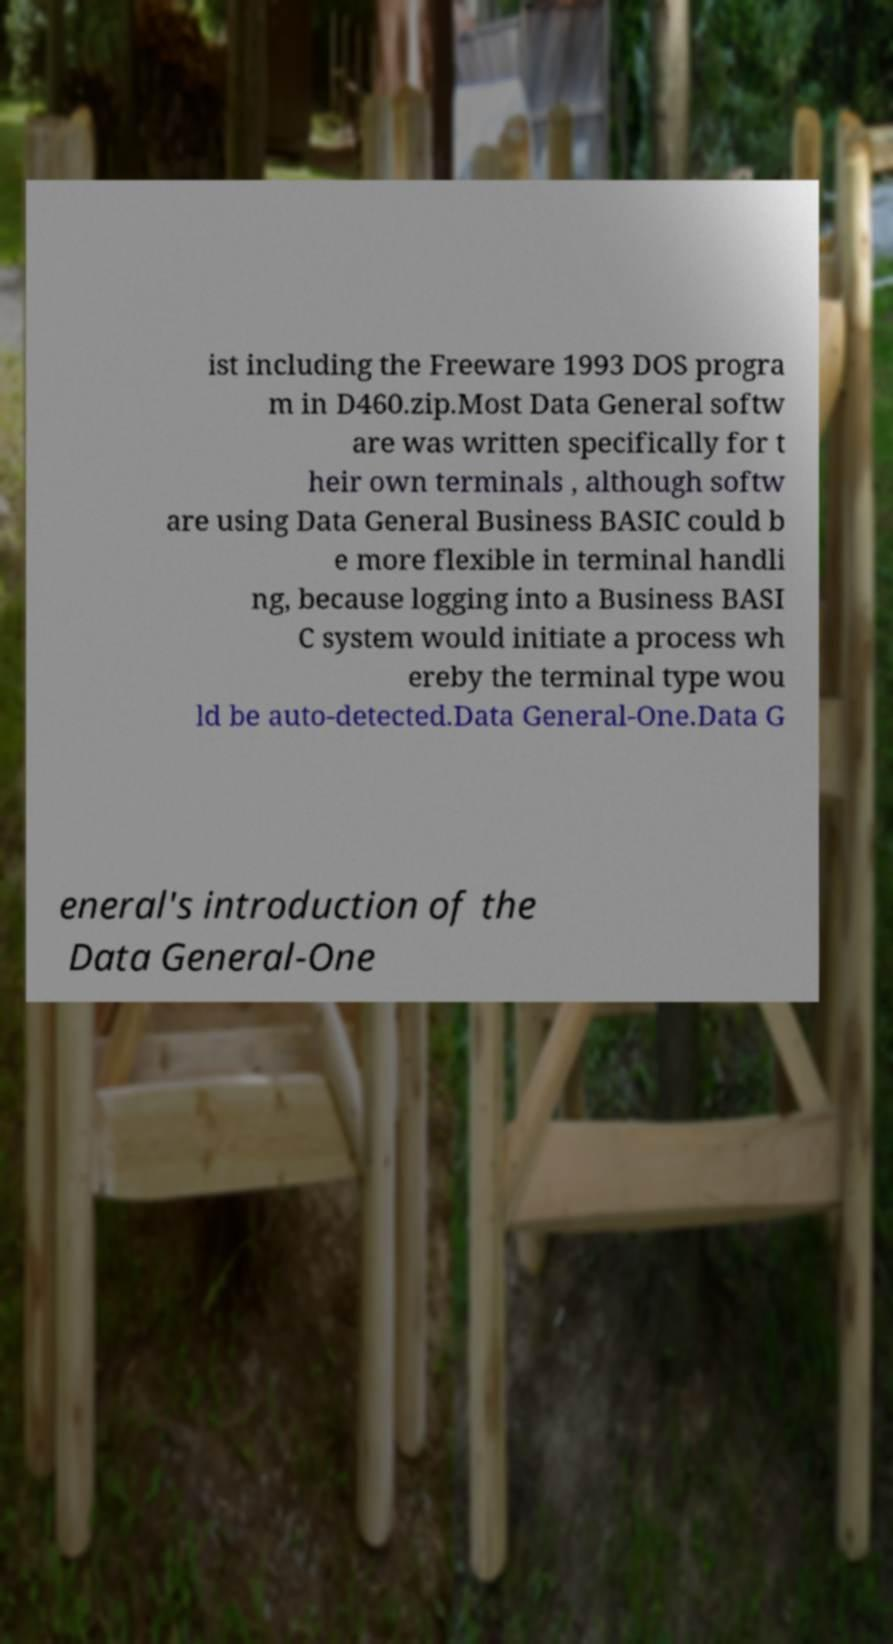Could you assist in decoding the text presented in this image and type it out clearly? ist including the Freeware 1993 DOS progra m in D460.zip.Most Data General softw are was written specifically for t heir own terminals , although softw are using Data General Business BASIC could b e more flexible in terminal handli ng, because logging into a Business BASI C system would initiate a process wh ereby the terminal type wou ld be auto-detected.Data General-One.Data G eneral's introduction of the Data General-One 